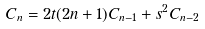<formula> <loc_0><loc_0><loc_500><loc_500>C _ { n } = 2 t ( 2 n + 1 ) C _ { n - 1 } + s ^ { 2 } C _ { n - 2 }</formula> 